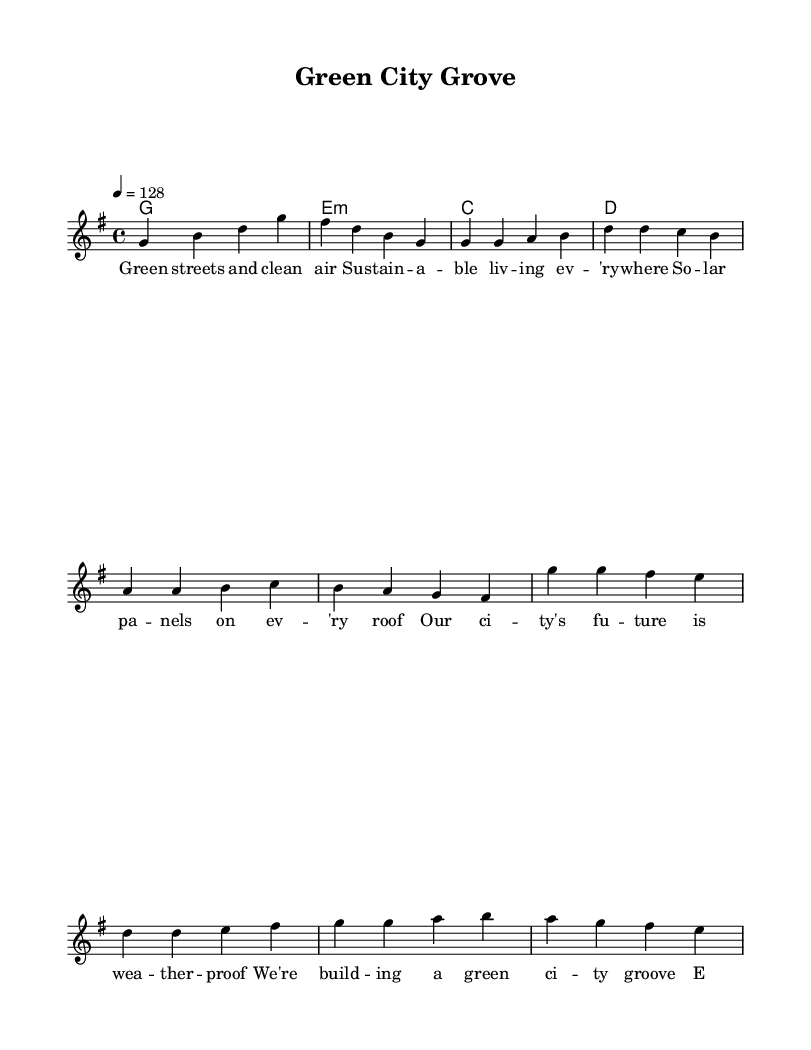What is the key signature of this music? The key signature is G major, which has one sharp (F#).
Answer: G major What is the time signature of this music? The time signature is 4/4, indicating four beats per measure and a quarter note receives one beat.
Answer: 4/4 What is the tempo of the piece? The tempo is marked at 128 beats per minute, suggesting an upbeat and lively pace suitable for house music.
Answer: 128 How many measures are in the verse section? The verse section consists of four measures, as indicated by the grouped notation in the score.
Answer: 4 What chords are used in the chorus? The chords used in the chorus are G major, E minor, C major, and D major, present in the harmonies section.
Answer: G, E minor, C, D What is the main theme of the lyrics? The lyrics focus on sustainability and eco-friendliness, highlighting themes of clean living and environmental responsibility.
Answer: Sustainability In what style of music is this piece categorized? This piece is categorized as upbeat house music, characterized by energetic rhythms and themes relevant to modern living and environmentalism.
Answer: House 